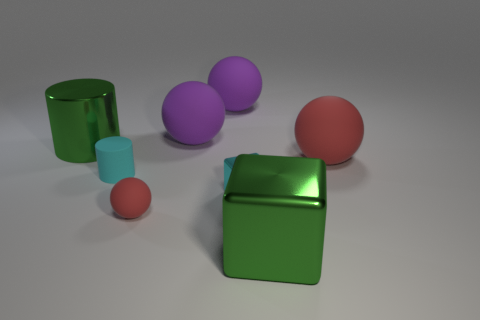What objects are in the foreground of the image? In the foreground, there appears to be one large green cylinder lying on its side and one small red sphere. And what about the background? In the background, you can see two large purple spheres along with one upright big green cylinder and a small blue cylinder next to it. Are there any patterns on any of the objects? No, the objects do not display any patterns. They are all solid colors. 